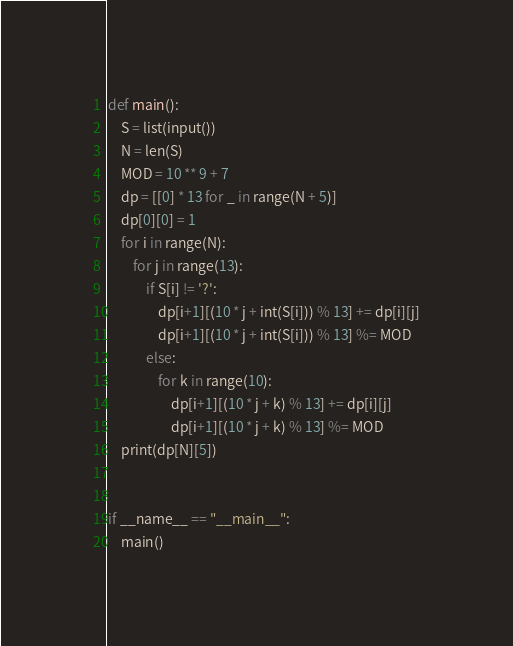Convert code to text. <code><loc_0><loc_0><loc_500><loc_500><_Python_>def main():
    S = list(input())
    N = len(S)
    MOD = 10 ** 9 + 7
    dp = [[0] * 13 for _ in range(N + 5)]
    dp[0][0] = 1
    for i in range(N):
        for j in range(13):
            if S[i] != '?':
                dp[i+1][(10 * j + int(S[i])) % 13] += dp[i][j]
                dp[i+1][(10 * j + int(S[i])) % 13] %= MOD
            else:
                for k in range(10):
                    dp[i+1][(10 * j + k) % 13] += dp[i][j]
                    dp[i+1][(10 * j + k) % 13] %= MOD
    print(dp[N][5])


if __name__ == "__main__":
    main()</code> 